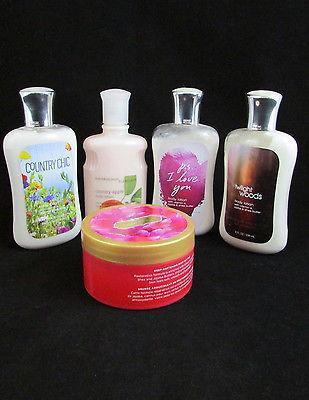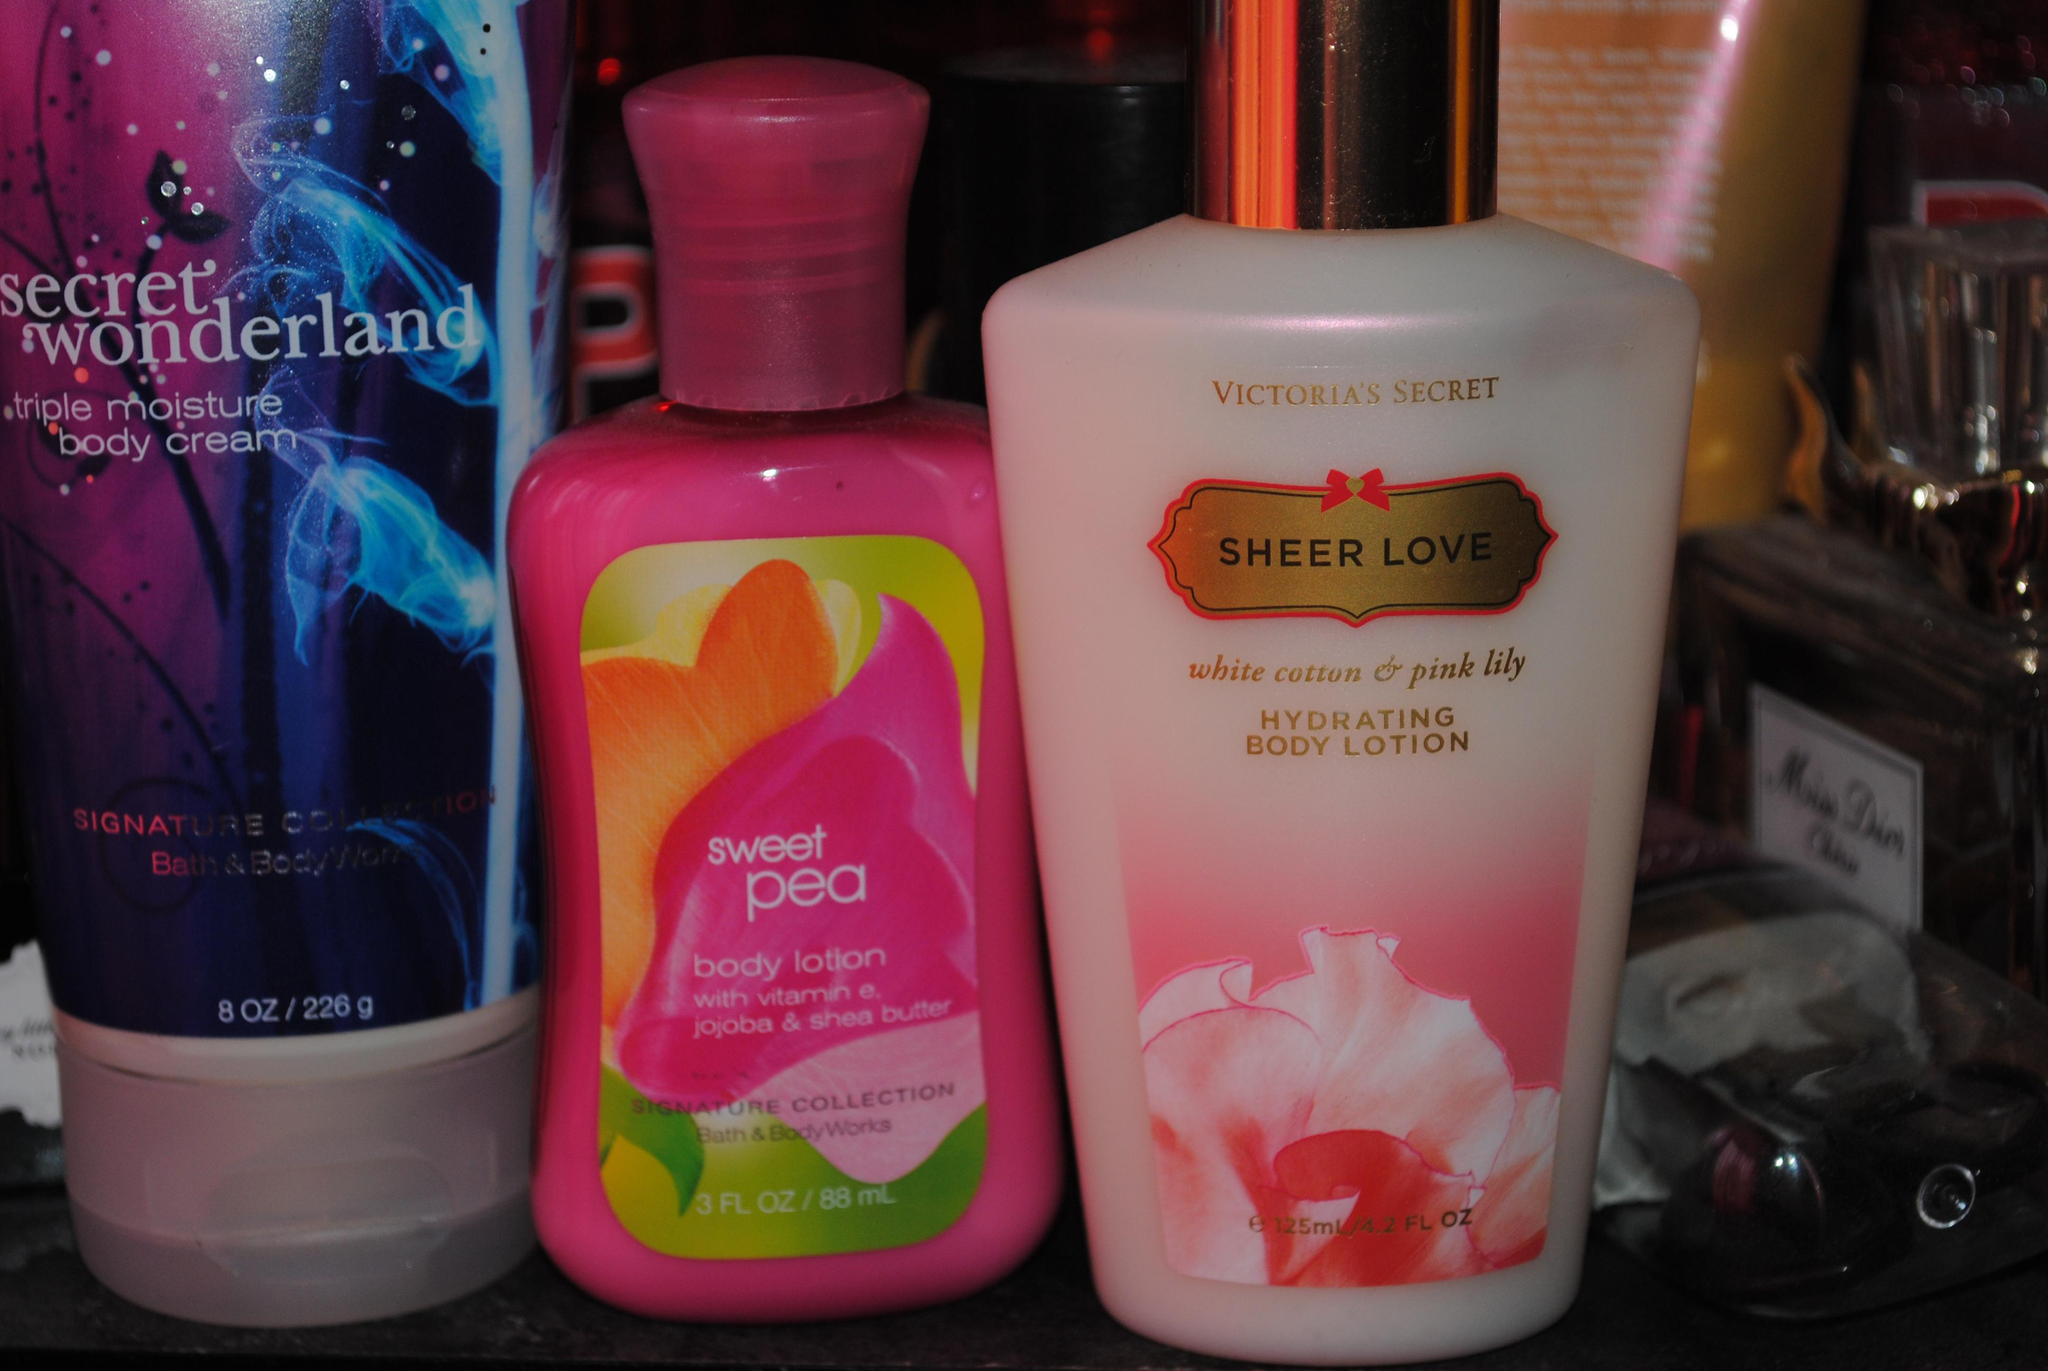The first image is the image on the left, the second image is the image on the right. Evaluate the accuracy of this statement regarding the images: "In one of the images there are seven containers lined up in a V shape.". Is it true? Answer yes or no. No. 